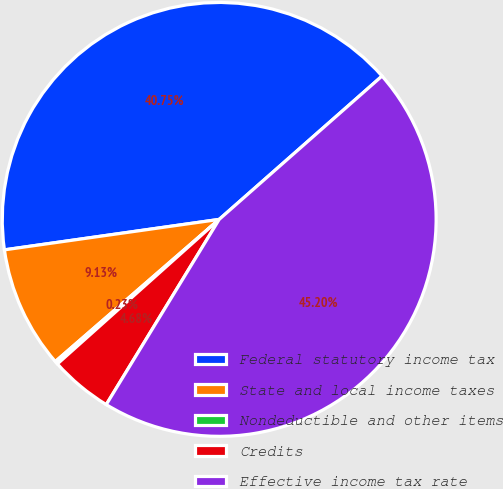Convert chart. <chart><loc_0><loc_0><loc_500><loc_500><pie_chart><fcel>Federal statutory income tax<fcel>State and local income taxes<fcel>Nondeductible and other items<fcel>Credits<fcel>Effective income tax rate<nl><fcel>40.75%<fcel>9.13%<fcel>0.23%<fcel>4.68%<fcel>45.2%<nl></chart> 